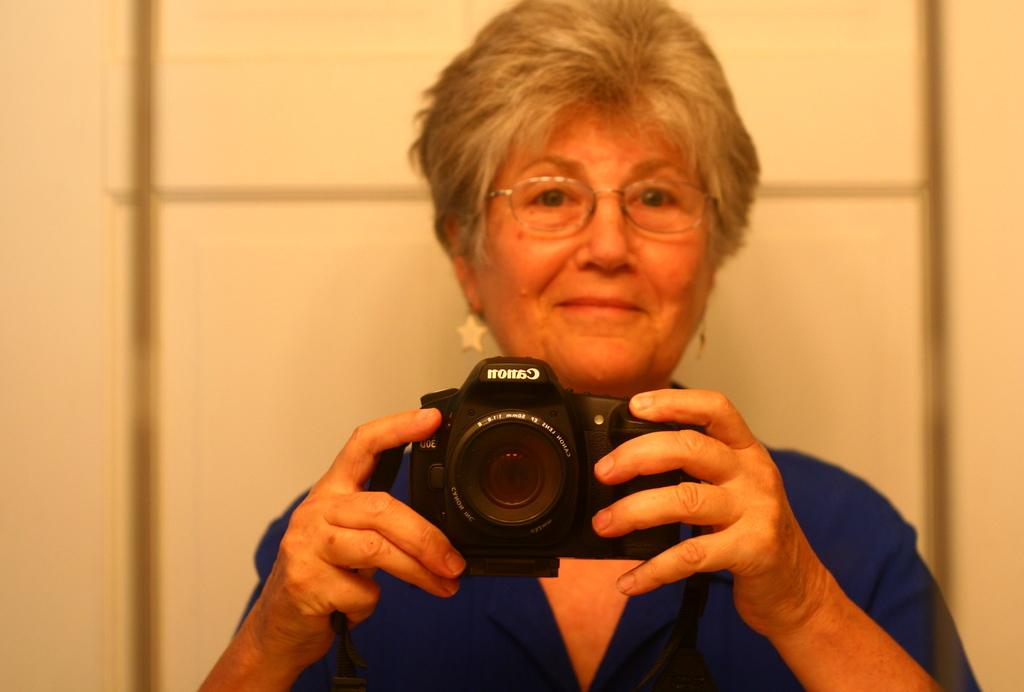Who is the main subject in the picture? There is a woman in the picture. What is the woman wearing? The woman is wearing a blue dress. What is the woman holding in the picture? The woman is holding a camera. What color is the background of the image? The background of the image is white. What type of payment is the woman receiving in the image? There is no indication in the image that the woman is receiving any payment. 